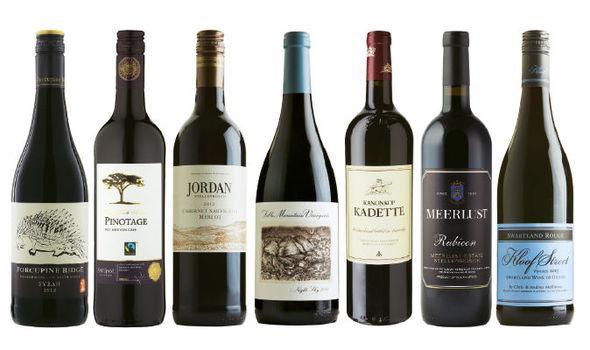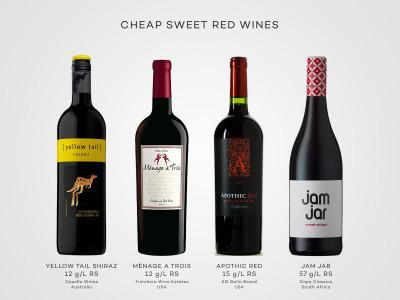The first image is the image on the left, the second image is the image on the right. For the images shown, is this caption "There are no more than five wine bottles in the left image." true? Answer yes or no. No. The first image is the image on the left, the second image is the image on the right. Assess this claim about the two images: "One of these images contains exactly four wine bottles.". Correct or not? Answer yes or no. Yes. 